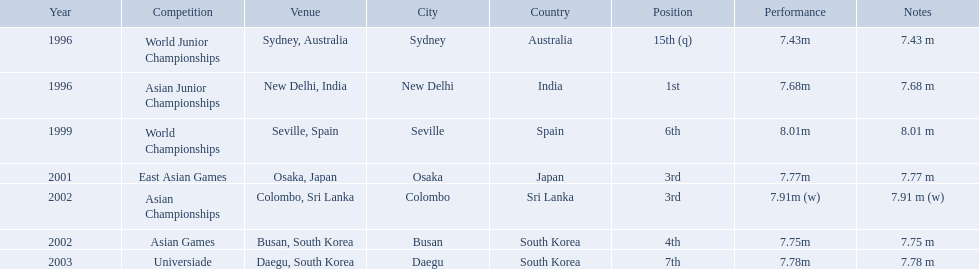What are all of the competitions? World Junior Championships, Asian Junior Championships, World Championships, East Asian Games, Asian Championships, Asian Games, Universiade. What was his positions in these competitions? 15th (q), 1st, 6th, 3rd, 3rd, 4th, 7th. And during which competition did he reach 1st place? Asian Junior Championships. What are the competitions that huang le participated in? World Junior Championships, Asian Junior Championships, World Championships, East Asian Games, Asian Championships, Asian Games, Universiade. Which competitions did he participate in 2002 Asian Championships, Asian Games. What are the lengths of his jumps that year? 7.91 m (w), 7.75 m. What is the longest length of a jump? 7.91 m (w). What competitions did huang le compete in? World Junior Championships, Asian Junior Championships, World Championships, East Asian Games, Asian Championships, Asian Games, Universiade. What distances did he achieve in these competitions? 7.43 m, 7.68 m, 8.01 m, 7.77 m, 7.91 m (w), 7.75 m, 7.78 m. Which of these distances was the longest? 7.91 m (w). 